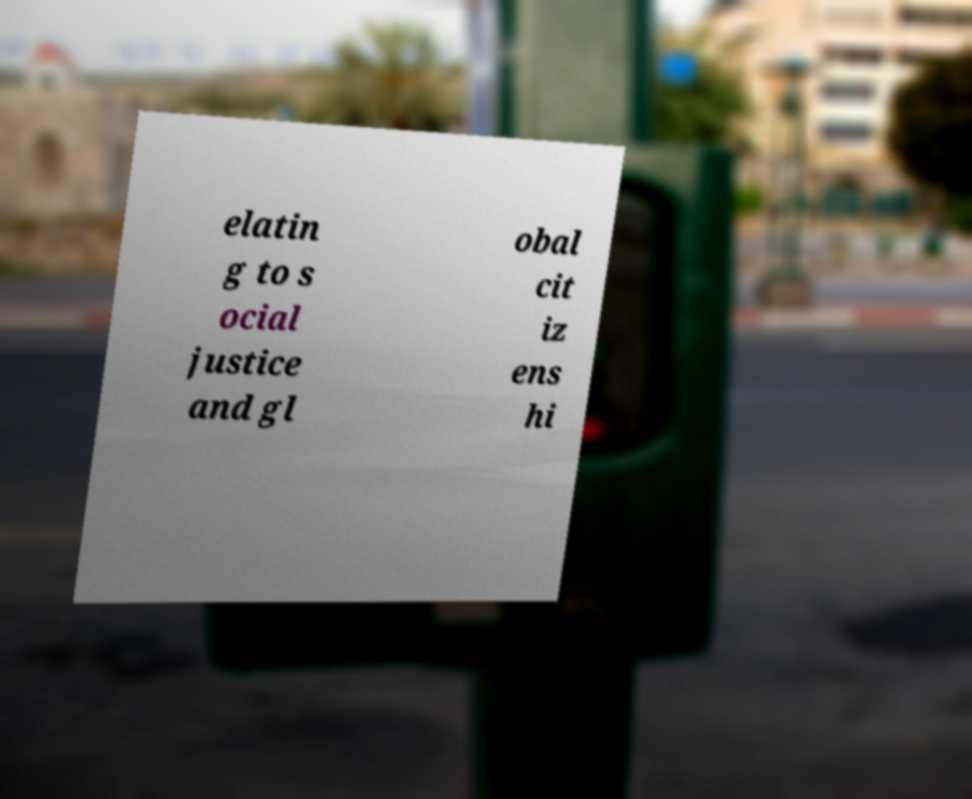Could you assist in decoding the text presented in this image and type it out clearly? elatin g to s ocial justice and gl obal cit iz ens hi 